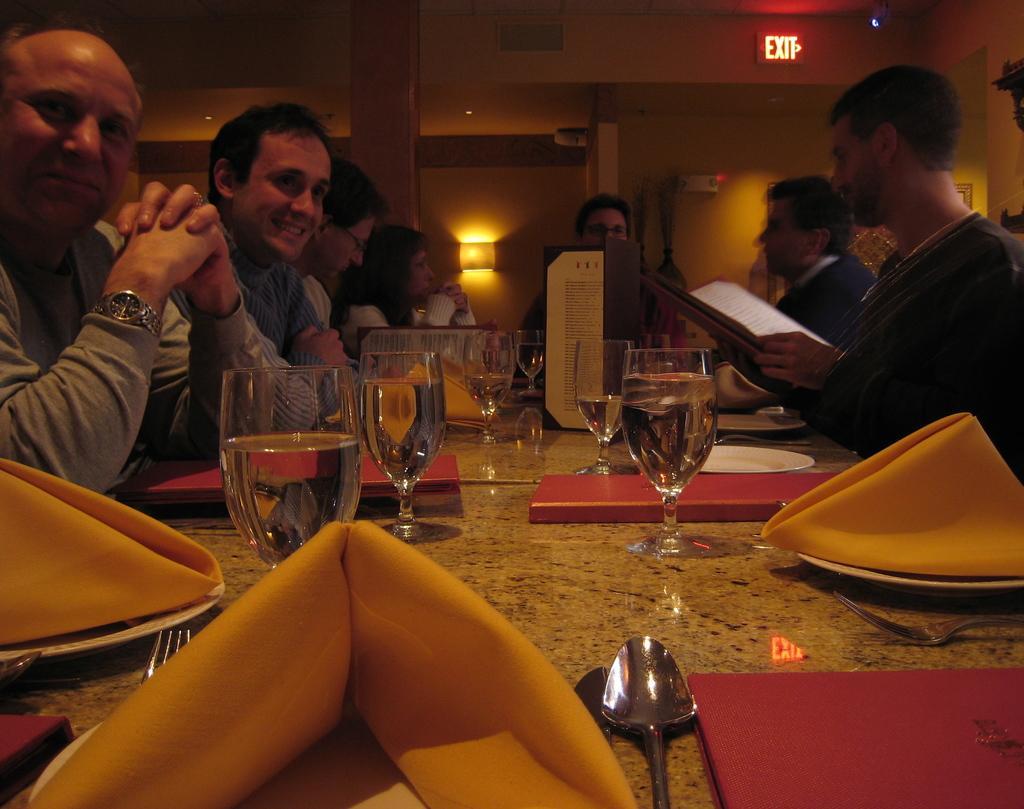How would you summarize this image in a sentence or two? There are many people sitting in front of the table. On the table there are some glasses, spoons,menu card, for,yellow color cloth. The man is holding a menu card in his hand. And there is a exit board on the top corner. 